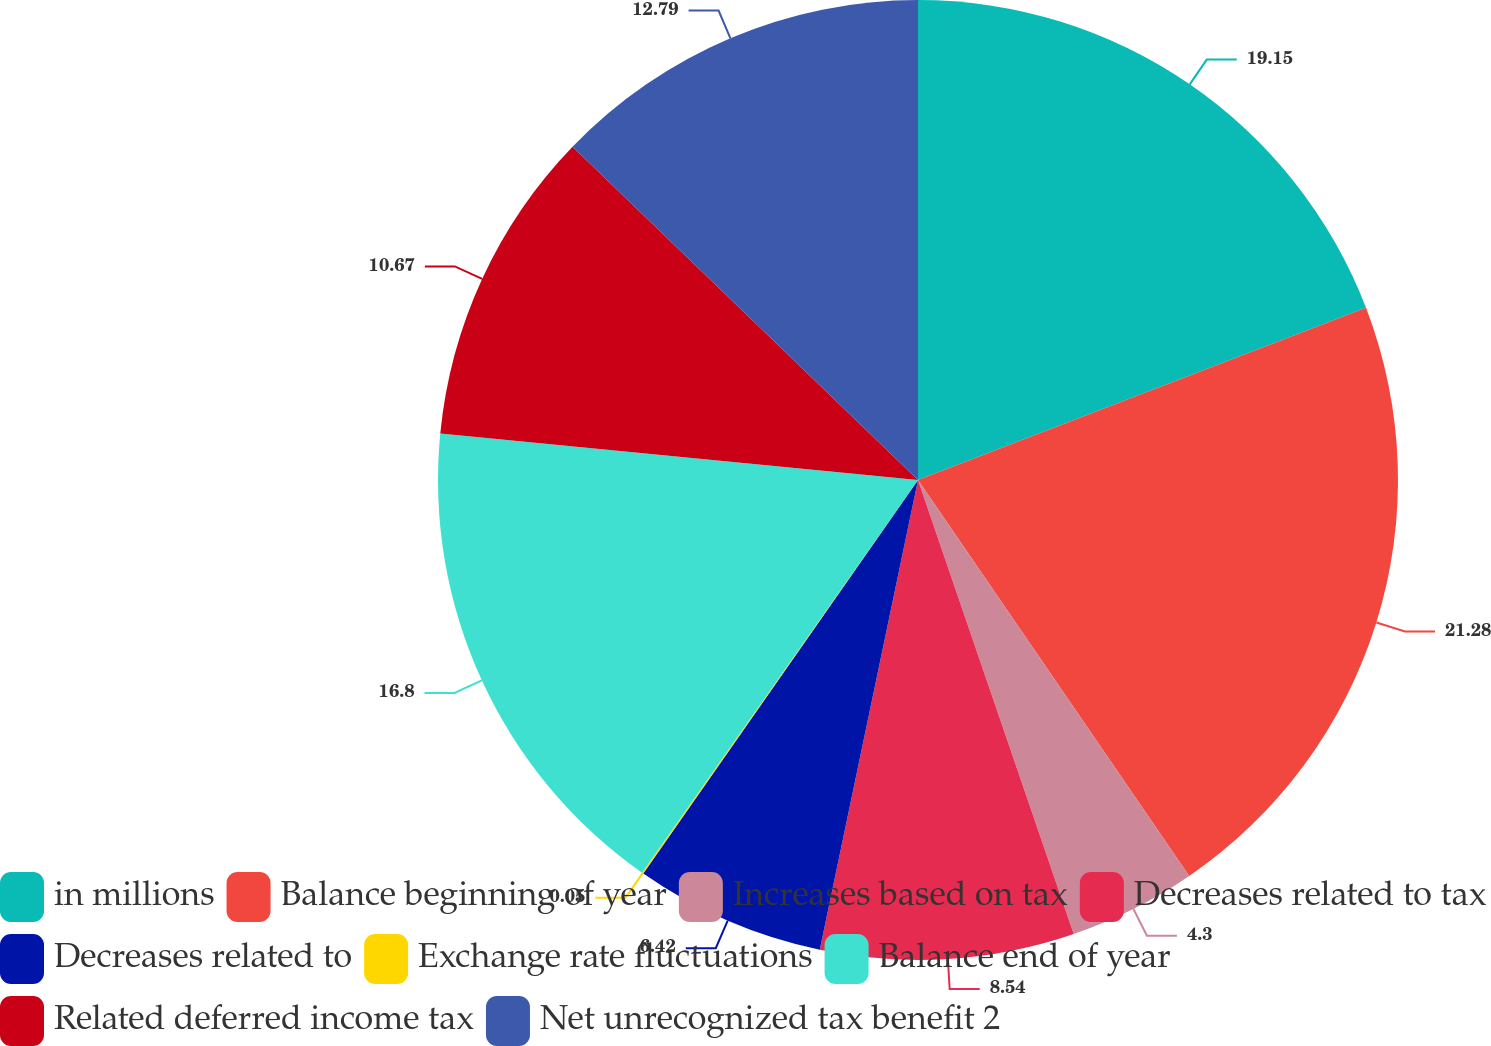Convert chart to OTSL. <chart><loc_0><loc_0><loc_500><loc_500><pie_chart><fcel>in millions<fcel>Balance beginning of year<fcel>Increases based on tax<fcel>Decreases related to tax<fcel>Decreases related to<fcel>Exchange rate fluctuations<fcel>Balance end of year<fcel>Related deferred income tax<fcel>Net unrecognized tax benefit 2<nl><fcel>19.16%<fcel>21.29%<fcel>4.3%<fcel>8.54%<fcel>6.42%<fcel>0.05%<fcel>16.8%<fcel>10.67%<fcel>12.79%<nl></chart> 